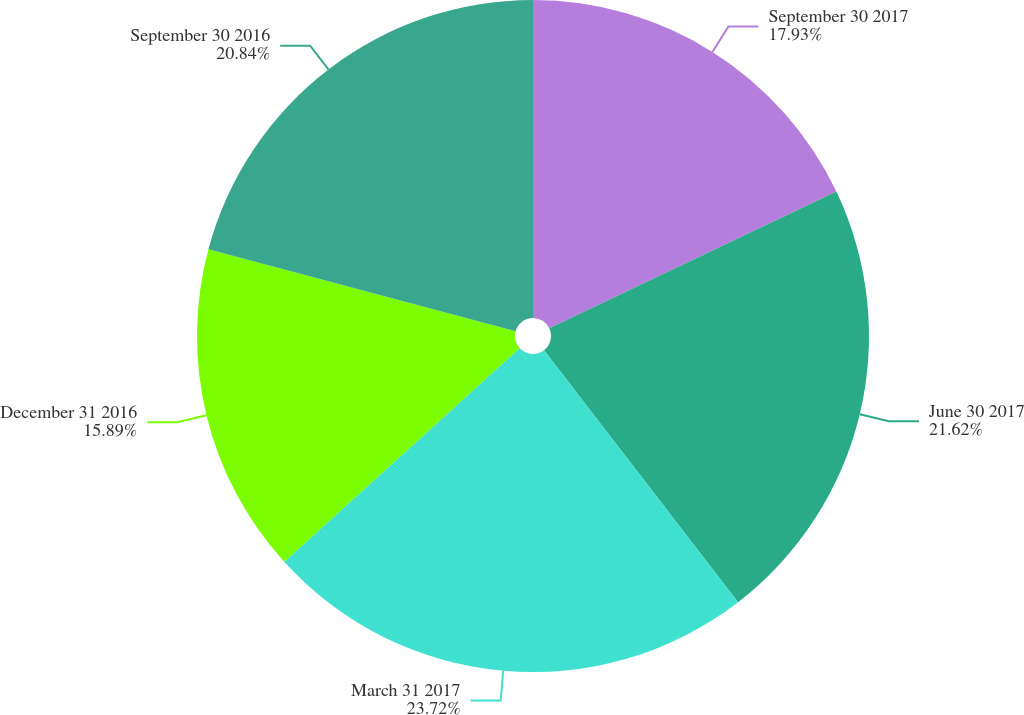Convert chart. <chart><loc_0><loc_0><loc_500><loc_500><pie_chart><fcel>September 30 2017<fcel>June 30 2017<fcel>March 31 2017<fcel>December 31 2016<fcel>September 30 2016<nl><fcel>17.93%<fcel>21.62%<fcel>23.72%<fcel>15.89%<fcel>20.84%<nl></chart> 